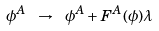Convert formula to latex. <formula><loc_0><loc_0><loc_500><loc_500>\phi ^ { A } \ \rightarrow \ \phi ^ { A } + F ^ { A } ( \phi ) \lambda</formula> 